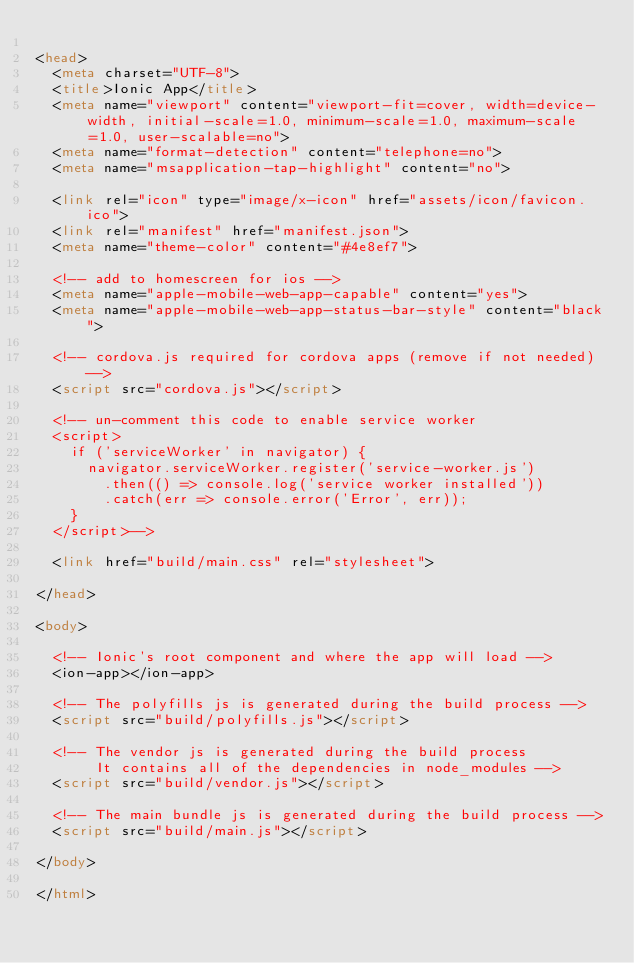<code> <loc_0><loc_0><loc_500><loc_500><_HTML_>
<head>
  <meta charset="UTF-8">
  <title>Ionic App</title>
  <meta name="viewport" content="viewport-fit=cover, width=device-width, initial-scale=1.0, minimum-scale=1.0, maximum-scale=1.0, user-scalable=no">
  <meta name="format-detection" content="telephone=no">
  <meta name="msapplication-tap-highlight" content="no">

  <link rel="icon" type="image/x-icon" href="assets/icon/favicon.ico">
  <link rel="manifest" href="manifest.json">
  <meta name="theme-color" content="#4e8ef7">

  <!-- add to homescreen for ios -->
  <meta name="apple-mobile-web-app-capable" content="yes">
  <meta name="apple-mobile-web-app-status-bar-style" content="black">

  <!-- cordova.js required for cordova apps (remove if not needed) -->
  <script src="cordova.js"></script>

  <!-- un-comment this code to enable service worker
  <script>
    if ('serviceWorker' in navigator) {
      navigator.serviceWorker.register('service-worker.js')
        .then(() => console.log('service worker installed'))
        .catch(err => console.error('Error', err));
    }
  </script>-->

  <link href="build/main.css" rel="stylesheet">

</head>

<body>

  <!-- Ionic's root component and where the app will load -->
  <ion-app></ion-app>

  <!-- The polyfills js is generated during the build process -->
  <script src="build/polyfills.js"></script>

  <!-- The vendor js is generated during the build process
       It contains all of the dependencies in node_modules -->
  <script src="build/vendor.js"></script>

  <!-- The main bundle js is generated during the build process -->
  <script src="build/main.js"></script>

</body>

</html></code> 